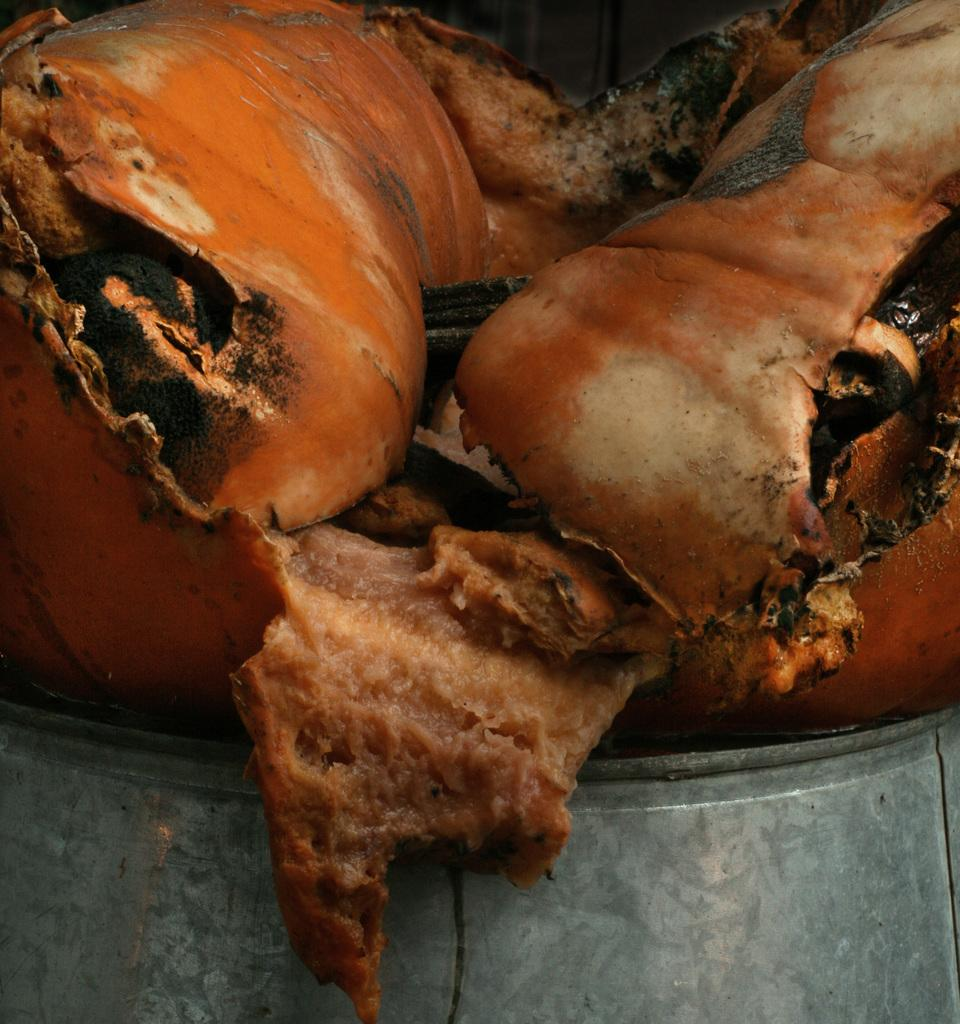What is the main subject in the center of the image? There is some meat in the center of the image. What is located at the bottom of the image? There is a table at the bottom of the image. What type of road can be seen in the image? There is no road present in the image. What color is the thread used to sew the baseball in the image? There is no thread or baseball present in the image. 